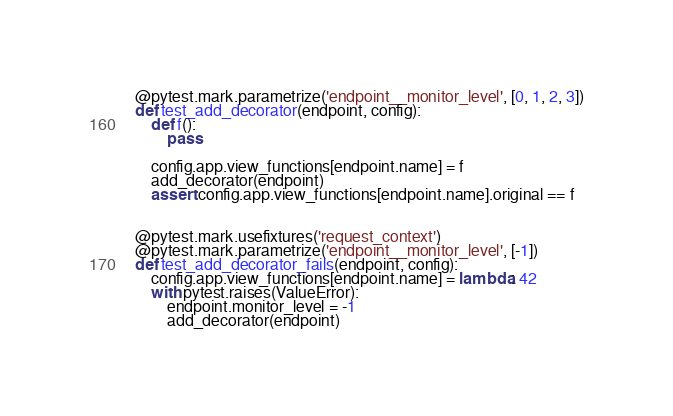<code> <loc_0><loc_0><loc_500><loc_500><_Python_>@pytest.mark.parametrize('endpoint__monitor_level', [0, 1, 2, 3])
def test_add_decorator(endpoint, config):
    def f():
        pass

    config.app.view_functions[endpoint.name] = f
    add_decorator(endpoint)
    assert config.app.view_functions[endpoint.name].original == f


@pytest.mark.usefixtures('request_context')
@pytest.mark.parametrize('endpoint__monitor_level', [-1])
def test_add_decorator_fails(endpoint, config):
    config.app.view_functions[endpoint.name] = lambda: 42
    with pytest.raises(ValueError):
        endpoint.monitor_level = -1
        add_decorator(endpoint)
</code> 